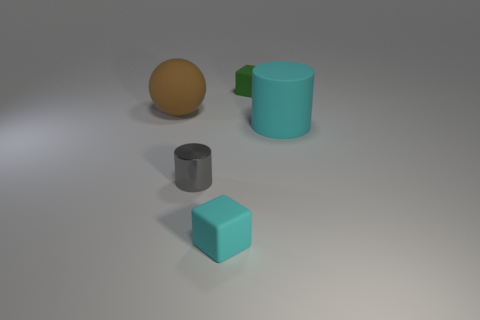Add 1 small brown metal things. How many objects exist? 6 Subtract all balls. How many objects are left? 4 Add 1 green rubber cylinders. How many green rubber cylinders exist? 1 Subtract 1 cyan cylinders. How many objects are left? 4 Subtract all brown metallic cylinders. Subtract all small gray metallic cylinders. How many objects are left? 4 Add 2 large cylinders. How many large cylinders are left? 3 